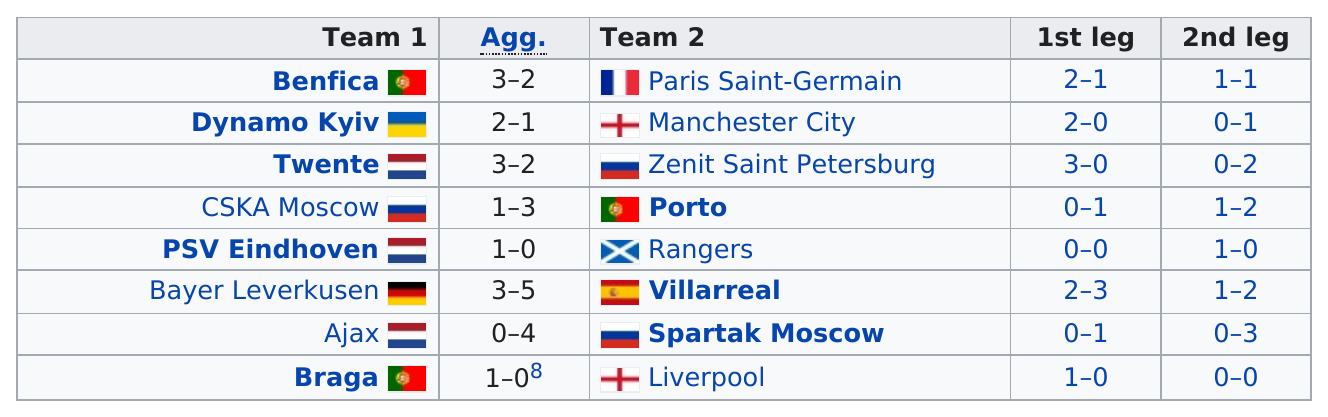Highlight a few significant elements in this photo. After Porto on Team 2, the next nation is Rangers. Braga had the same aggregated score as PSV Eindhoven in the round of 16, demonstrating their strong performance and competitiveness in the competition. What is the total number of nations in team 1? There were two legs present. According to the information available, Ajax did not score more points than Porto. 